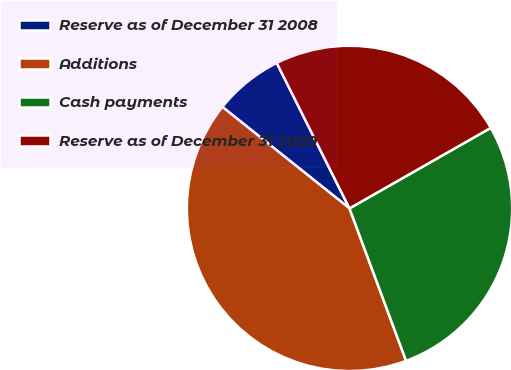Convert chart to OTSL. <chart><loc_0><loc_0><loc_500><loc_500><pie_chart><fcel>Reserve as of December 31 2008<fcel>Additions<fcel>Cash payments<fcel>Reserve as of December 31 2009<nl><fcel>6.9%<fcel>41.38%<fcel>27.59%<fcel>24.14%<nl></chart> 